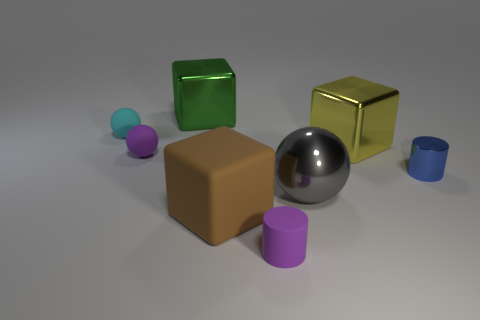What is the material of the small thing that is the same color as the matte cylinder?
Provide a succinct answer. Rubber. There is a purple object in front of the blue cylinder that is behind the cube that is in front of the small shiny thing; what size is it?
Keep it short and to the point. Small. What number of gray things are metal spheres or rubber cubes?
Ensure brevity in your answer.  1. What is the shape of the purple thing that is behind the small cylinder that is on the left side of the blue object?
Provide a short and direct response. Sphere. There is a sphere that is on the right side of the green metallic object; does it have the same size as the metal cube in front of the green shiny thing?
Provide a short and direct response. Yes. Is there a large yellow cylinder that has the same material as the tiny blue object?
Your answer should be very brief. No. There is a matte sphere that is the same color as the tiny rubber cylinder; what is its size?
Your response must be concise. Small. There is a small cylinder in front of the cylinder that is to the right of the large shiny ball; is there a large thing that is on the left side of it?
Give a very brief answer. Yes. Are there any large yellow metallic things on the left side of the small cyan object?
Your answer should be very brief. No. There is a matte thing behind the yellow cube; what number of big yellow shiny things are on the left side of it?
Offer a terse response. 0. 